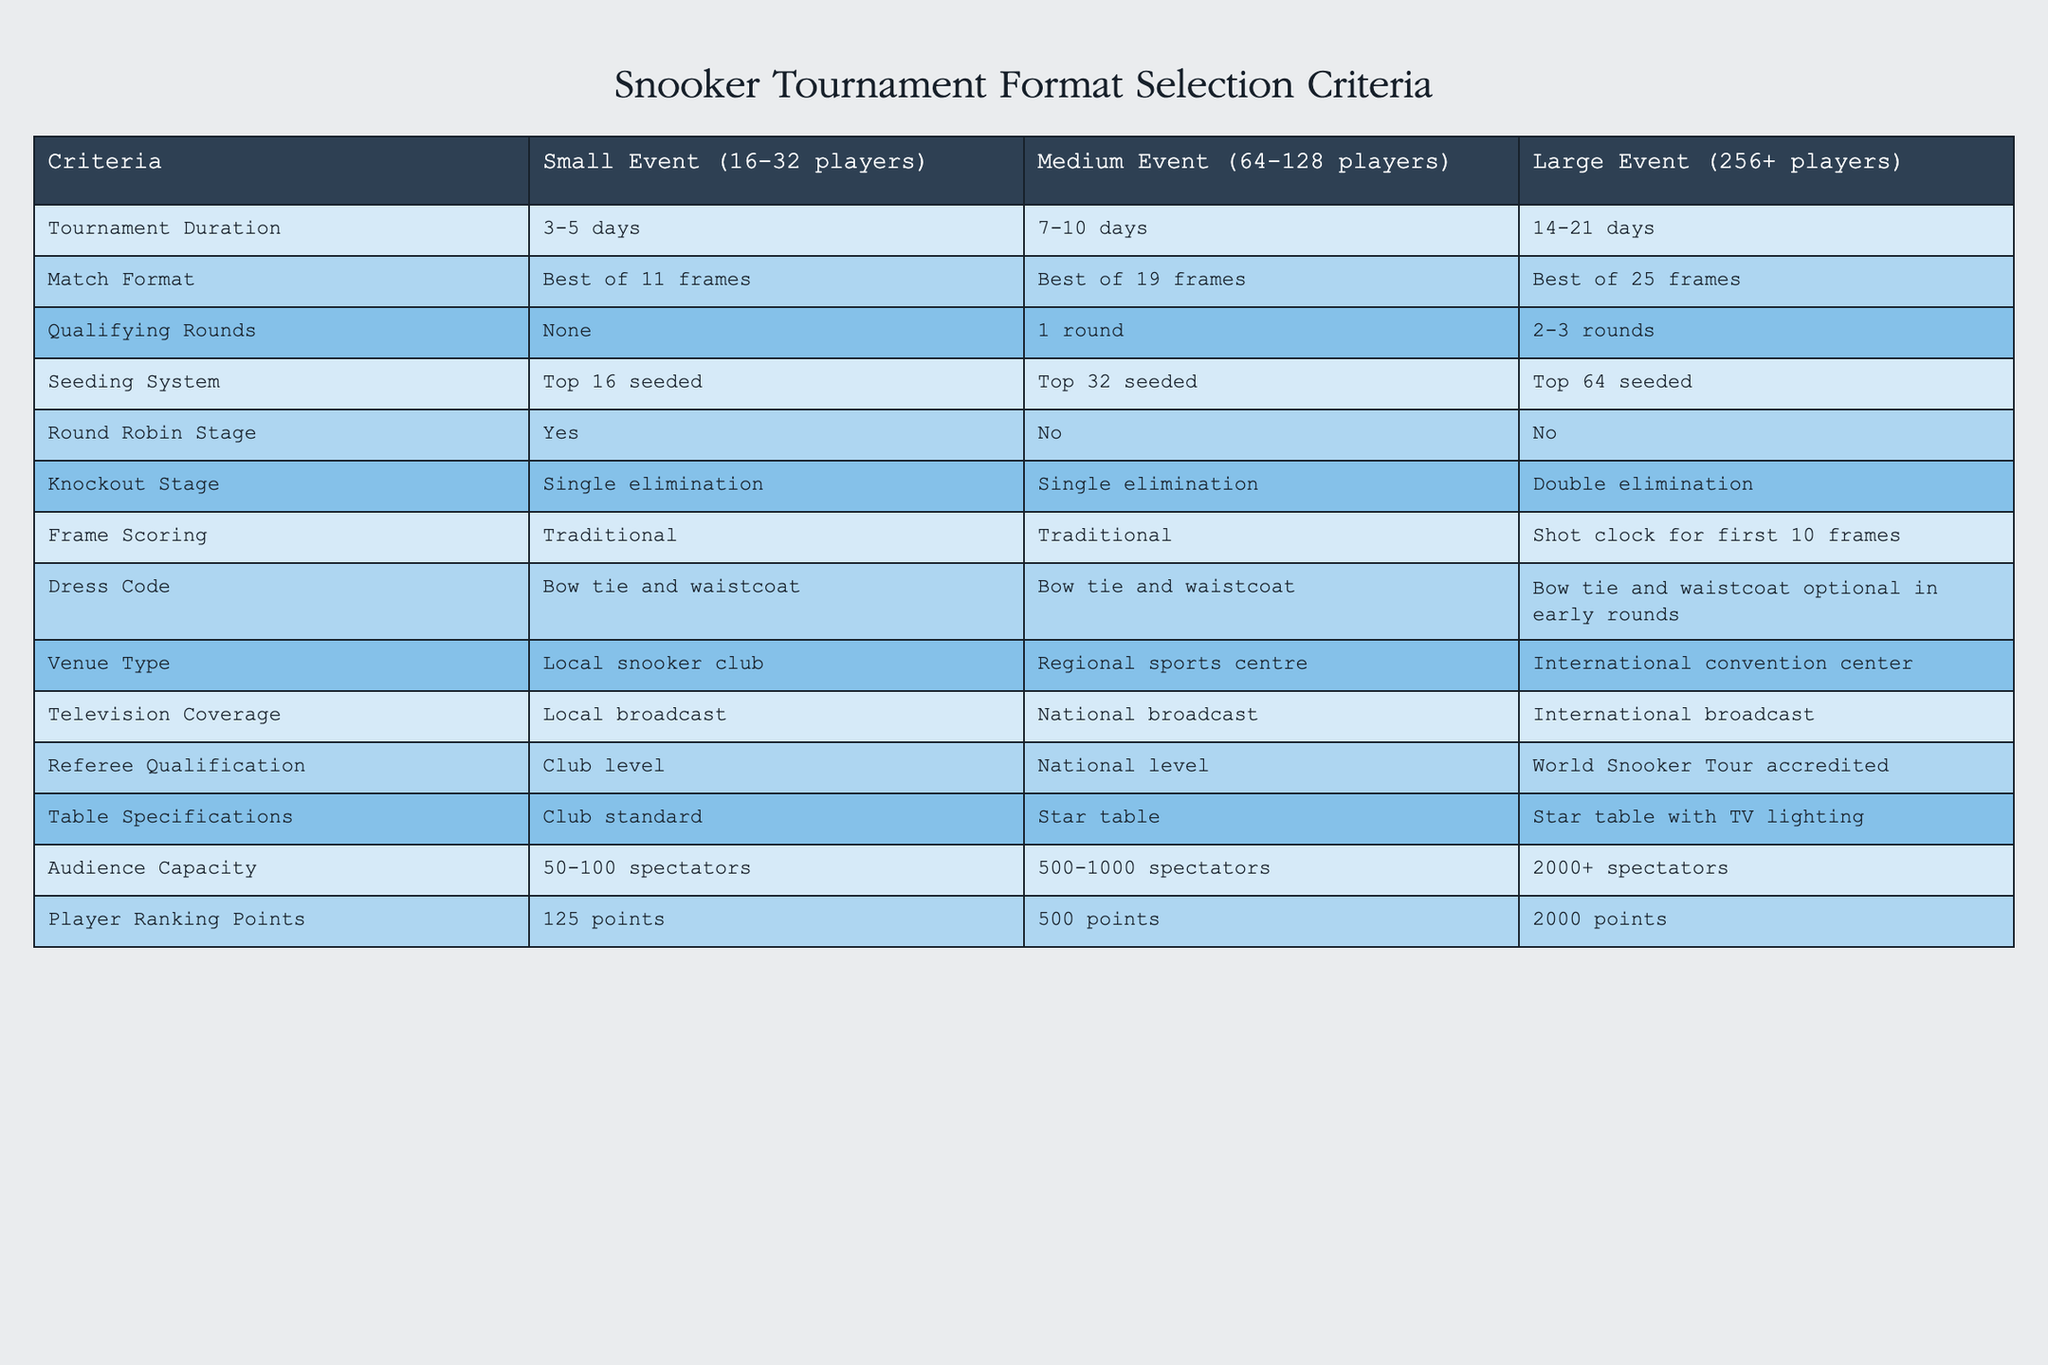What is the match format for a medium-sized snooker event? According to the table, the match format for a medium event (64-128 players) is "Best of 19 frames."
Answer: Best of 19 frames How many spectator capacity is expected for a large snooker tournament? The table specifies that a large event (256+ players) has an audience capacity of "2000+ spectators."
Answer: 2000+ spectators Is there a qualifying round for small-sized events? Referring to the table, there are no qualifying rounds mentioned for small events (16-32 players), so the answer is "No."
Answer: No What is the difference in tournament duration between medium and large events? The tournament duration for medium events is "7-10 days" while for large events it is "14-21 days." The difference is calculated as follows: 14 - 7 = 7 days to 21 - 10 = 11 days. Thus, the tournament duration for large events is 7 to 11 days longer than for medium events.
Answer: 7 to 11 days longer Do large events have a round robin stage? Based on the table, large events (256+ players) do not include a round robin stage, which is marked as "No."
Answer: No What is the player ranking point difference between a small and large tournament? For small events, players earn 125 points while for large events, they earn 2000 points. The difference is calculated as 2000 - 125 = 1875, meaning that players can earn 1875 more points in large events compared to small events.
Answer: 1875 points In terms of referee qualification, how does a small event differ from a large event? The table shows that small events (16-32 players) require club-level referees, while large events (256+ players) require World Snooker Tour accredited referees. This indicates a significant difference in the requirement for referee qualification.
Answer: Larger events require more qualified referees Is the dress code the same for all event sizes? The table indicates that the dress code for small and medium events is "Bow tie and waistcoat," while for large events, it is "Bow tie and waistcoat optional in early rounds." Therefore, the dress code is slightly more relaxed for large events.
Answer: No, it varies slightly What venue type is used for small events, and how does it compare to large events? Small events are held at a "Local snooker club" while large events take place at an "International convention center." This indicates a shift from a more local venue for small events to a more significant, international venue for larger events.
Answer: Local club vs. International convention center 